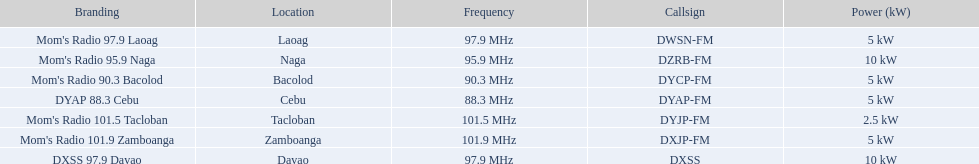Which stations broadcast in dyap-fm? Mom's Radio 97.9 Laoag, Mom's Radio 95.9 Naga, Mom's Radio 90.3 Bacolod, DYAP 88.3 Cebu, Mom's Radio 101.5 Tacloban, Mom's Radio 101.9 Zamboanga, DXSS 97.9 Davao. Of those stations which broadcast in dyap-fm, which stations broadcast with 5kw of power or under? Mom's Radio 97.9 Laoag, Mom's Radio 90.3 Bacolod, DYAP 88.3 Cebu, Mom's Radio 101.5 Tacloban, Mom's Radio 101.9 Zamboanga. Of those stations that broadcast with 5kw of power or under, which broadcasts with the least power? Mom's Radio 101.5 Tacloban. 